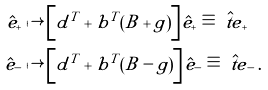Convert formula to latex. <formula><loc_0><loc_0><loc_500><loc_500>\hat { e } _ { + } & \mapsto \left [ d ^ { T } + b ^ { T } ( B + g ) \right ] \hat { e } _ { + } \equiv \hat { \ t e } _ { + } \\ \hat { e } _ { - } & \mapsto \left [ d ^ { T } + b ^ { T } ( B - g ) \right ] \hat { e } _ { - } \equiv \hat { \ t e } _ { - } \, .</formula> 